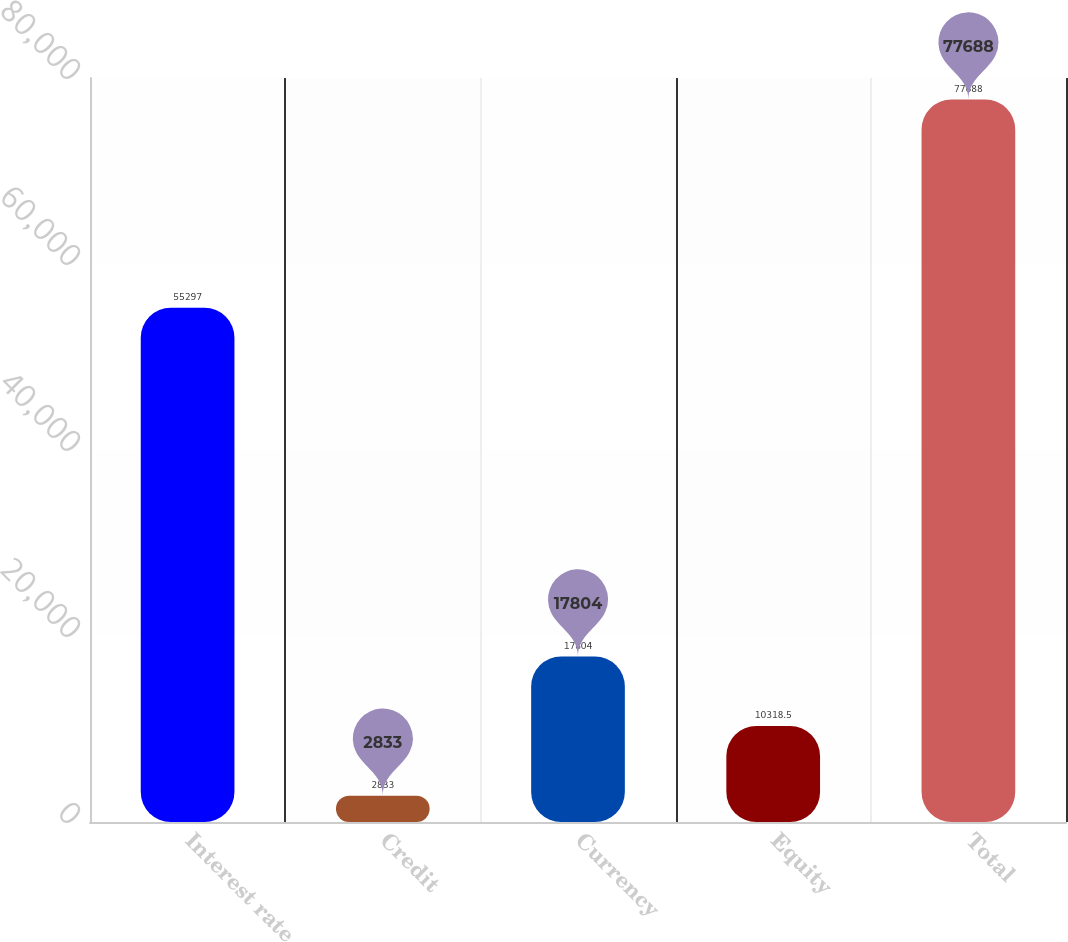<chart> <loc_0><loc_0><loc_500><loc_500><bar_chart><fcel>Interest rate<fcel>Credit<fcel>Currency<fcel>Equity<fcel>Total<nl><fcel>55297<fcel>2833<fcel>17804<fcel>10318.5<fcel>77688<nl></chart> 